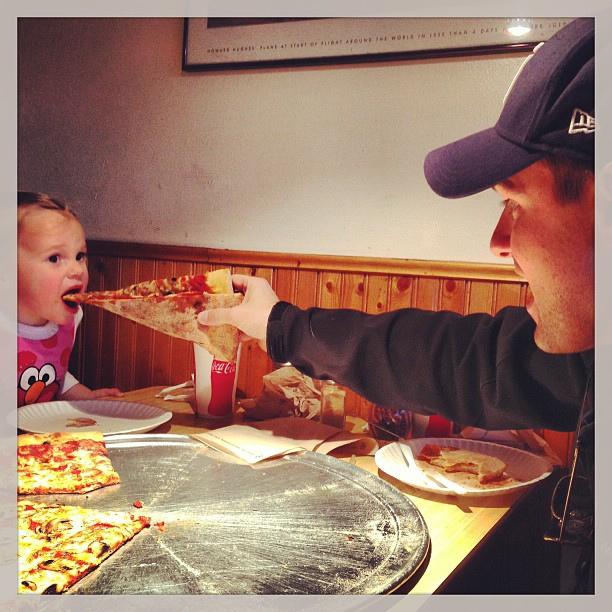Are bananas in the picture?
Write a very short answer. No. Is the man in a suit?
Concise answer only. No. Is the girl taking a bite of pizza that is fresh?
Concise answer only. Yes. Where is the partially eaten pizza on this table?
Give a very brief answer. On pan. What is on the child's shirt?
Quick response, please. Elmo. 